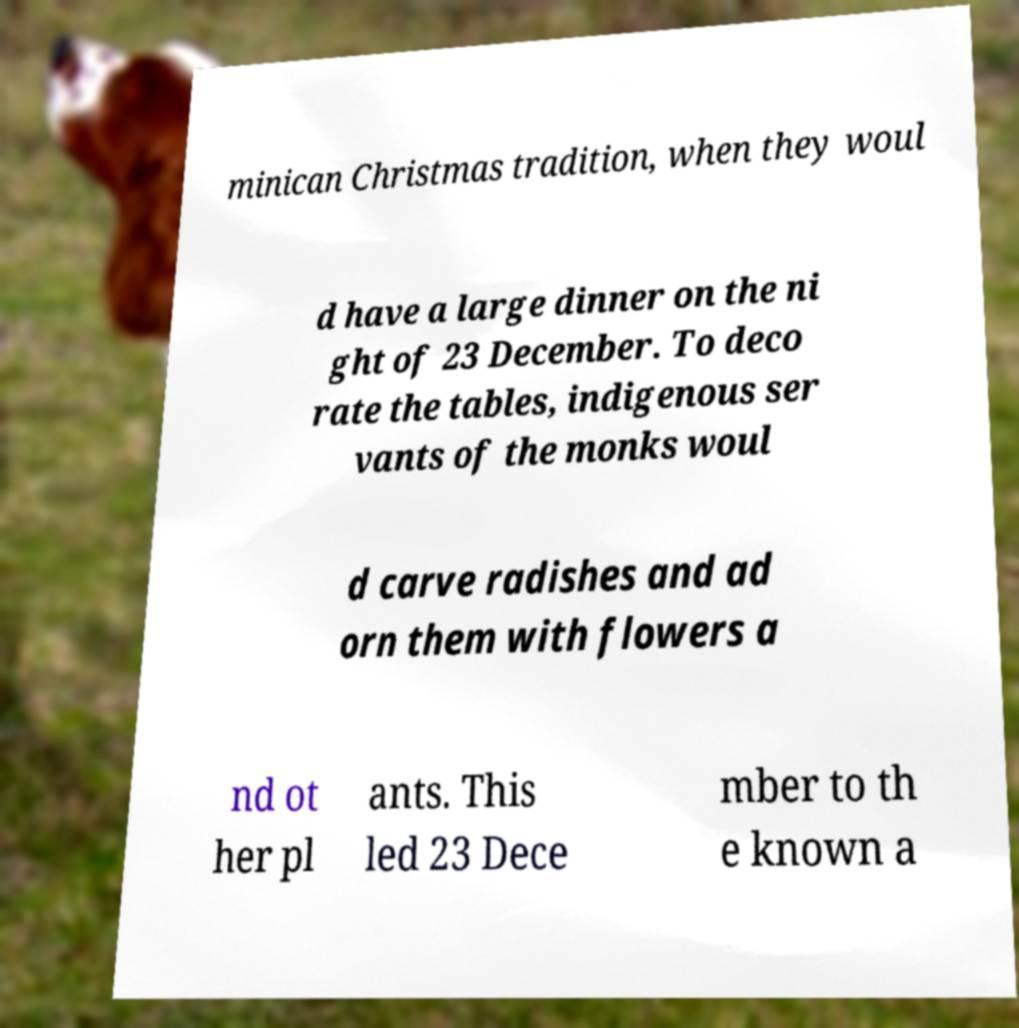Can you accurately transcribe the text from the provided image for me? minican Christmas tradition, when they woul d have a large dinner on the ni ght of 23 December. To deco rate the tables, indigenous ser vants of the monks woul d carve radishes and ad orn them with flowers a nd ot her pl ants. This led 23 Dece mber to th e known a 